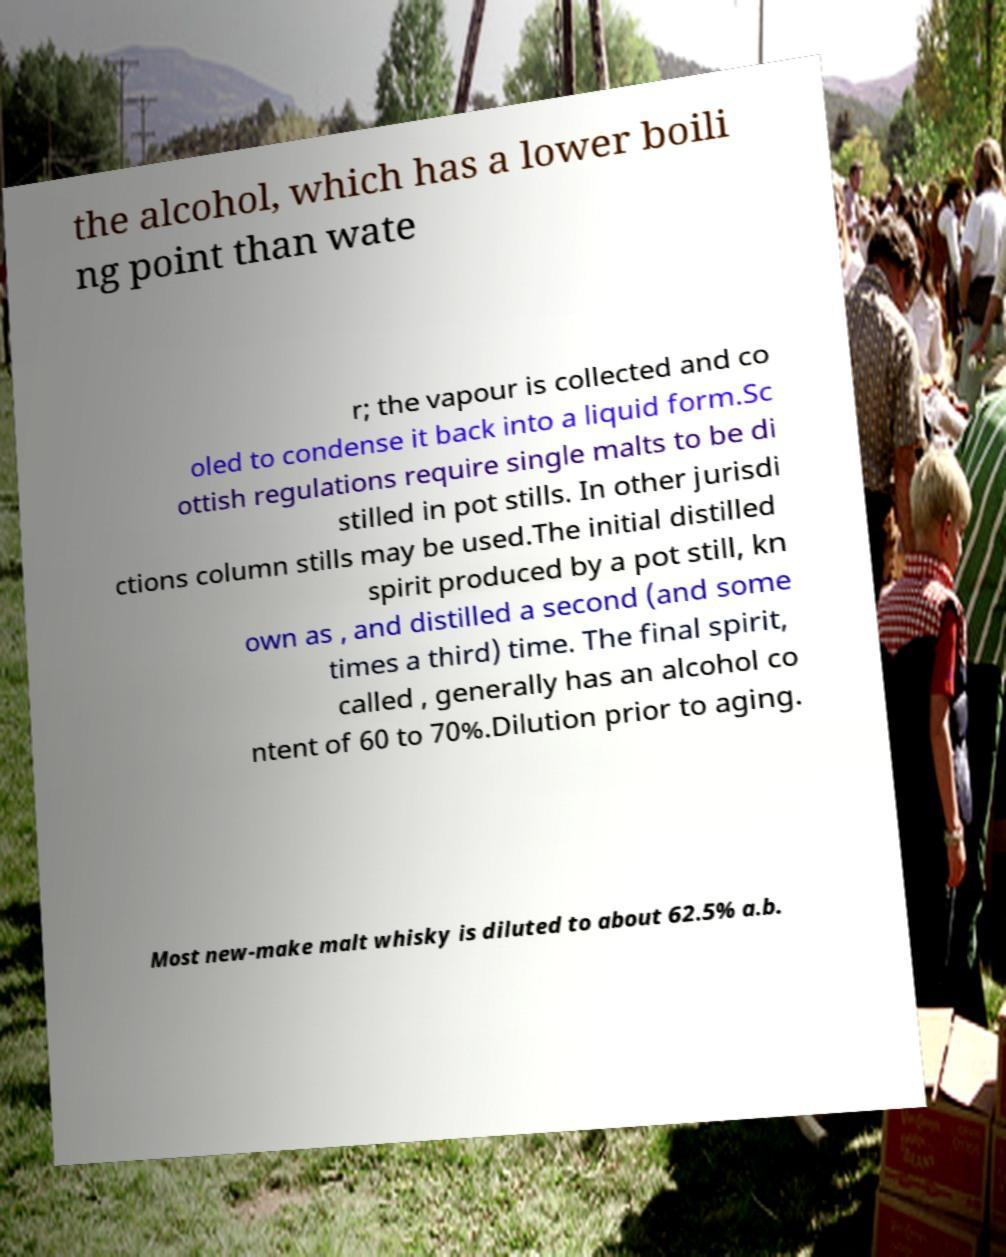Could you assist in decoding the text presented in this image and type it out clearly? the alcohol, which has a lower boili ng point than wate r; the vapour is collected and co oled to condense it back into a liquid form.Sc ottish regulations require single malts to be di stilled in pot stills. In other jurisdi ctions column stills may be used.The initial distilled spirit produced by a pot still, kn own as , and distilled a second (and some times a third) time. The final spirit, called , generally has an alcohol co ntent of 60 to 70%.Dilution prior to aging. Most new-make malt whisky is diluted to about 62.5% a.b. 